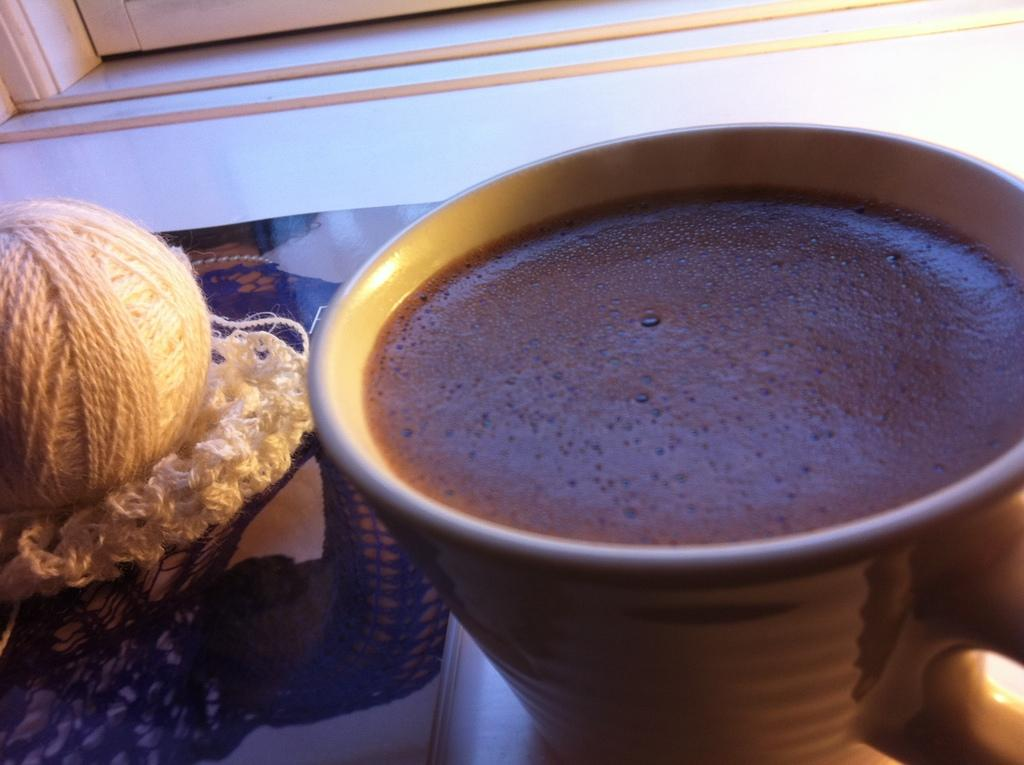What beverage is in the cup that is visible in the image? There is a cup of coffee in the image. What object is on the cover of the cup? There is a woolen ball on the cover. What type of structure can be seen in the background of the image? There is a door in the background of the image. What type of nail is being hammered into the wall in the image? There is no nail or wall present in the image; it only features a cup of coffee with a woolen ball on the cover and a door in the background. 